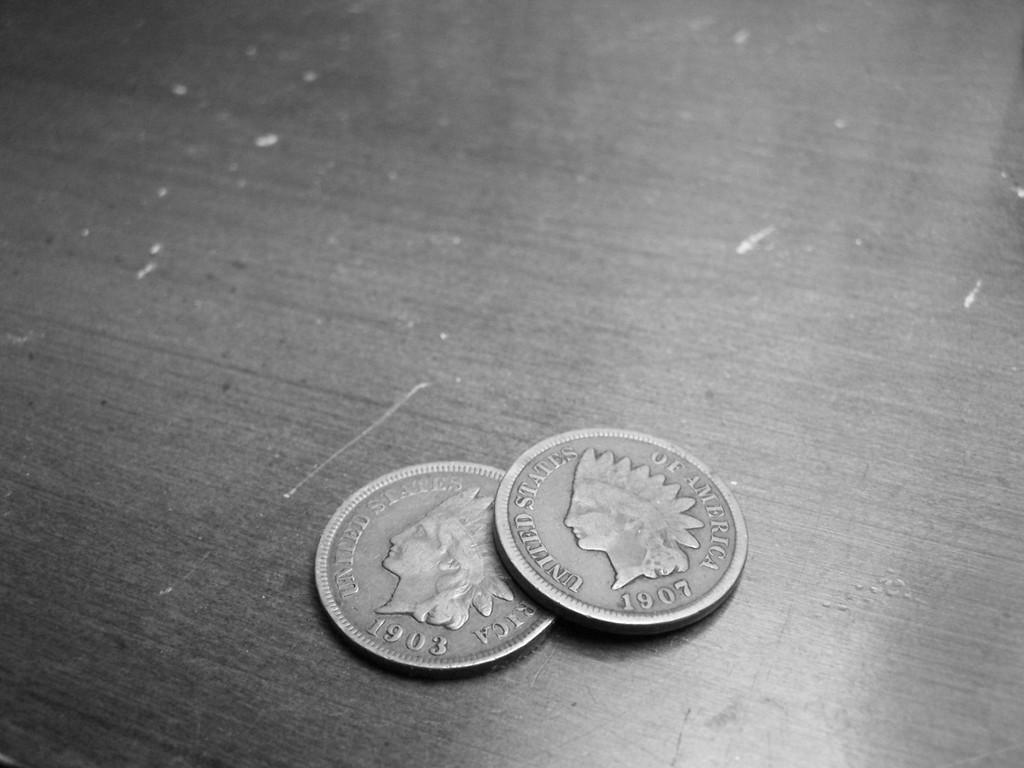<image>
Share a concise interpretation of the image provided. Two United States Indian head pennies from 1903 and 1907. 